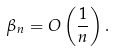Convert formula to latex. <formula><loc_0><loc_0><loc_500><loc_500>\beta _ { n } = O \left ( \frac { 1 } { n } \right ) .</formula> 